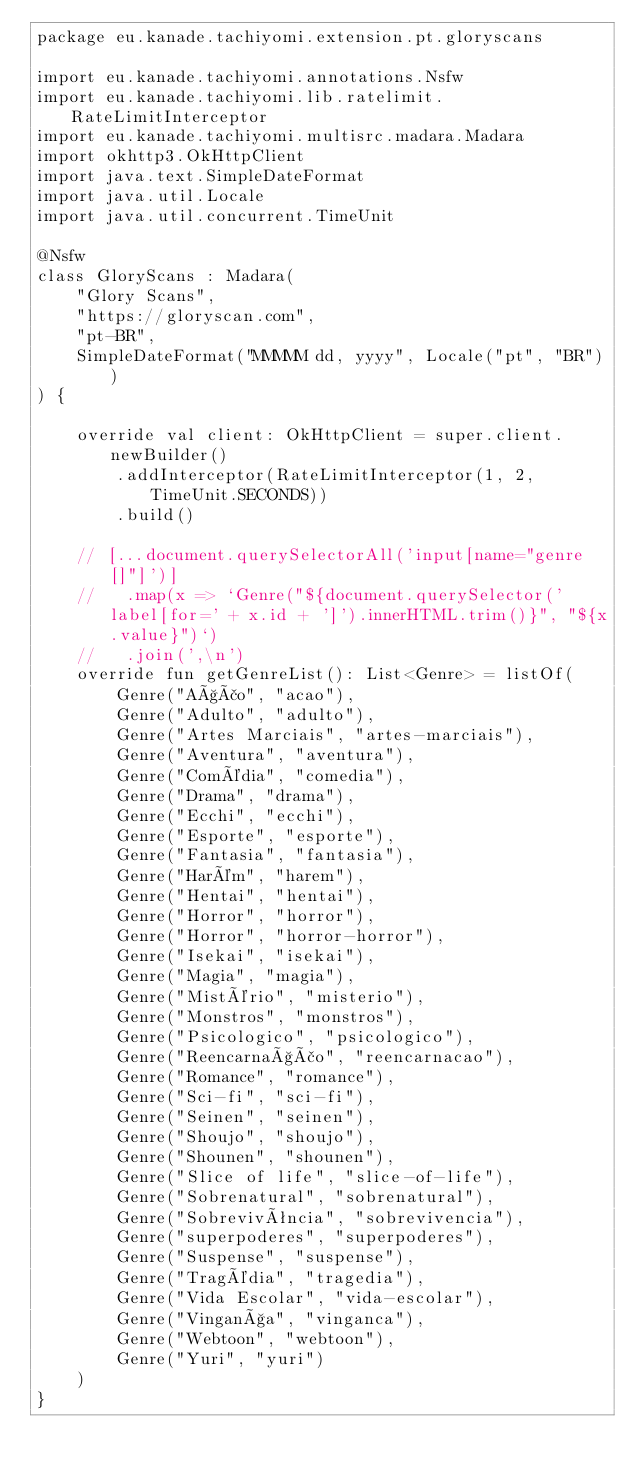<code> <loc_0><loc_0><loc_500><loc_500><_Kotlin_>package eu.kanade.tachiyomi.extension.pt.gloryscans

import eu.kanade.tachiyomi.annotations.Nsfw
import eu.kanade.tachiyomi.lib.ratelimit.RateLimitInterceptor
import eu.kanade.tachiyomi.multisrc.madara.Madara
import okhttp3.OkHttpClient
import java.text.SimpleDateFormat
import java.util.Locale
import java.util.concurrent.TimeUnit

@Nsfw
class GloryScans : Madara(
    "Glory Scans",
    "https://gloryscan.com",
    "pt-BR",
    SimpleDateFormat("MMMMM dd, yyyy", Locale("pt", "BR"))
) {

    override val client: OkHttpClient = super.client.newBuilder()
        .addInterceptor(RateLimitInterceptor(1, 2, TimeUnit.SECONDS))
        .build()

    // [...document.querySelectorAll('input[name="genre[]"]')]
    //   .map(x => `Genre("${document.querySelector('label[for=' + x.id + ']').innerHTML.trim()}", "${x.value}")`)
    //   .join(',\n')
    override fun getGenreList(): List<Genre> = listOf(
        Genre("Ação", "acao"),
        Genre("Adulto", "adulto"),
        Genre("Artes Marciais", "artes-marciais"),
        Genre("Aventura", "aventura"),
        Genre("Comédia", "comedia"),
        Genre("Drama", "drama"),
        Genre("Ecchi", "ecchi"),
        Genre("Esporte", "esporte"),
        Genre("Fantasia", "fantasia"),
        Genre("Harém", "harem"),
        Genre("Hentai", "hentai"),
        Genre("Horror", "horror"),
        Genre("Horror", "horror-horror"),
        Genre("Isekai", "isekai"),
        Genre("Magia", "magia"),
        Genre("Mistério", "misterio"),
        Genre("Monstros", "monstros"),
        Genre("Psicologico", "psicologico"),
        Genre("Reencarnação", "reencarnacao"),
        Genre("Romance", "romance"),
        Genre("Sci-fi", "sci-fi"),
        Genre("Seinen", "seinen"),
        Genre("Shoujo", "shoujo"),
        Genre("Shounen", "shounen"),
        Genre("Slice of life", "slice-of-life"),
        Genre("Sobrenatural", "sobrenatural"),
        Genre("Sobrevivência", "sobrevivencia"),
        Genre("superpoderes", "superpoderes"),
        Genre("Suspense", "suspense"),
        Genre("Tragédia", "tragedia"),
        Genre("Vida Escolar", "vida-escolar"),
        Genre("Vingança", "vinganca"),
        Genre("Webtoon", "webtoon"),
        Genre("Yuri", "yuri")
    )
}
</code> 